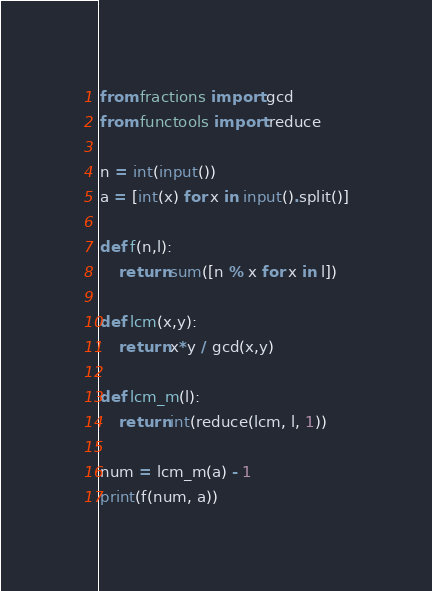Convert code to text. <code><loc_0><loc_0><loc_500><loc_500><_Python_>from fractions import gcd
from functools import reduce

n = int(input())
a = [int(x) for x in input().split()]

def f(n,l):
    return sum([n % x for x in l])

def lcm(x,y):
    return x*y / gcd(x,y)

def lcm_m(l):
    return int(reduce(lcm, l, 1))

num = lcm_m(a) - 1
print(f(num, a))
</code> 